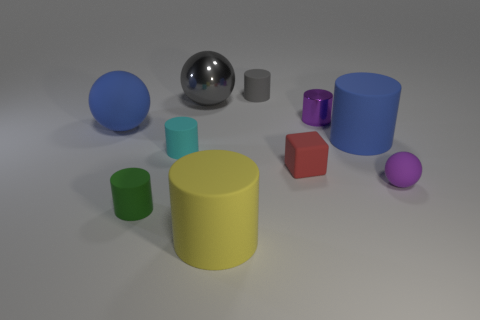How many big things are blue spheres or metallic cylinders?
Ensure brevity in your answer.  1. There is a large rubber object that is in front of the ball that is in front of the large blue object on the left side of the small green rubber thing; what is its color?
Make the answer very short. Yellow. How many other things are the same color as the large matte ball?
Keep it short and to the point. 1. How many metal things are tiny purple cylinders or tiny gray cylinders?
Your answer should be very brief. 1. Is the color of the rubber ball on the right side of the blue matte cylinder the same as the big rubber object behind the large blue cylinder?
Make the answer very short. No. Are there any other things that have the same material as the yellow object?
Your response must be concise. Yes. What is the size of the blue thing that is the same shape as the small green matte thing?
Provide a succinct answer. Large. Is the number of small cylinders to the left of the cyan cylinder greater than the number of red matte cubes?
Offer a very short reply. No. Is the material of the purple cylinder that is right of the big blue rubber sphere the same as the blue cylinder?
Keep it short and to the point. No. There is a gray thing that is to the left of the large object in front of the rubber ball that is right of the shiny cylinder; what size is it?
Ensure brevity in your answer.  Large. 